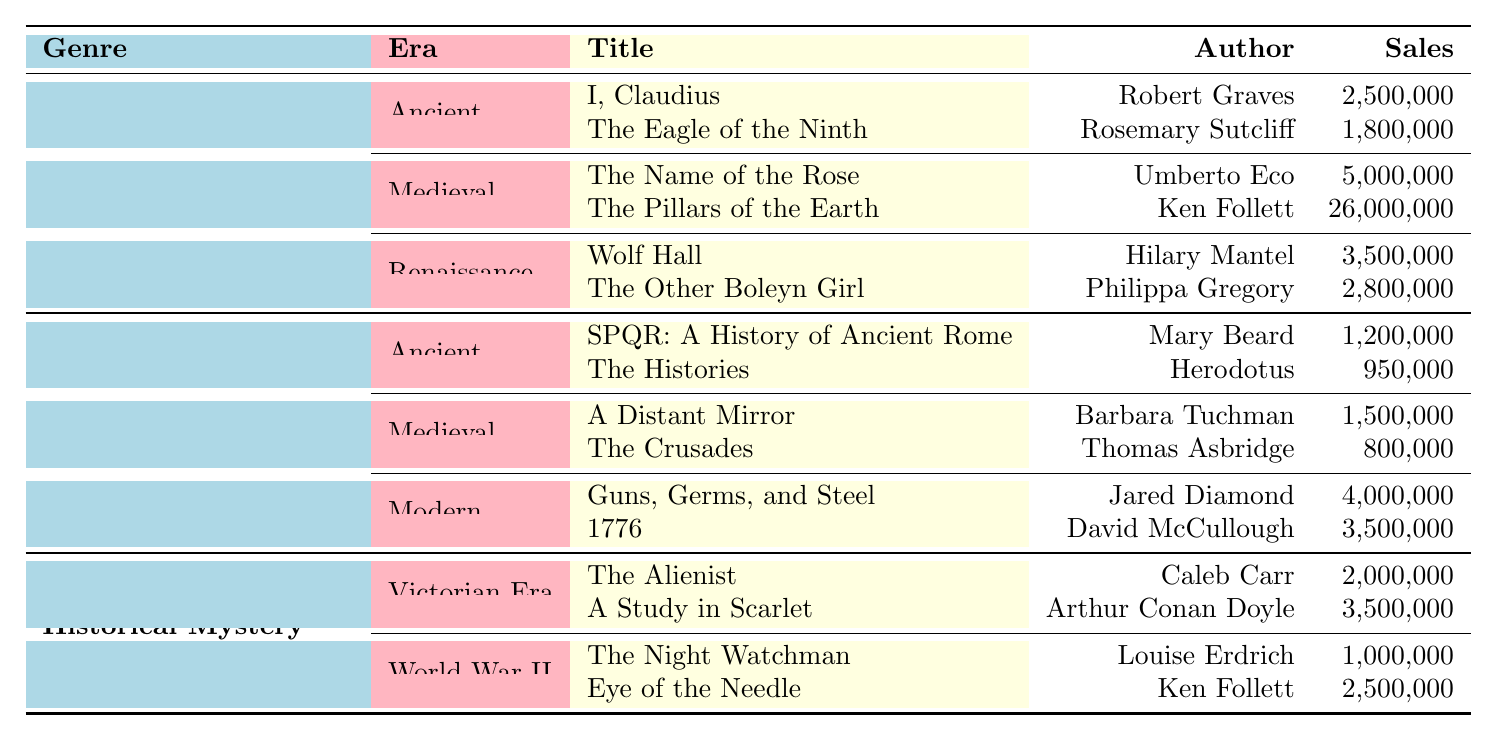What is the highest-selling historical fiction book listed? From the Historical Fiction section, "The Pillars of the Earth" by Ken Follett is shown to have sales of 26,000,000, which is higher than any other title in that category.
Answer: The Pillars of the Earth Which author has the highest total sales in historical fiction? To find the highest total sales by an author in historical fiction, we add the sales of "The Pillars of the Earth" (26,000,000) and "The Name of the Rose" (5,000,000) by Ken Follett and Umberto Eco, respectively. Ken Follett has the highest total sales of 26 million alone.
Answer: Ken Follett Is "The Histories" older than "Guns, Germs, and Steel"? "The Histories" by Herodotus was published in 1954 whereas "Guns, Germs, and Steel" by Jared Diamond was published in 1997. So yes, "The Histories" is older.
Answer: Yes What are the total sales of all the books under Historical Non-Fiction? We sum the sales of all books in Historical Non-Fiction: 1,200,000 + 950,000 + 1,500,000 + 800,000 + 4,000,000 + 3,500,000 = 12,950,000.
Answer: 12,950,000 How many books have sales exceeding 3 million? Counting the titles listed with sales over 3 million: "The Pillars of the Earth" (26,000,000), "The Name of the Rose" (5,000,000), "1776" (3,500,000), and "A Study in Scarlet" (3,500,000) gives us a total of 4 books.
Answer: 4 What is the average sales figure for historical mysteries? The total sales for historical mysteries: 2,000,000 + 3,500,000 + 1,000,000 + 2,500,000 = 9,000,000. There are 4 titles, so we divide: 9,000,000 / 4 = 2,250,000.
Answer: 2,250,000 Which genre has the highest total sales across all its time periods? We calculate the total sales for each genre: Historical Fiction = 2,500,000 + 1,800,000 + 5,000,000 + 26,000,000 + 3,500,000 + 2,800,000 = 42,600,000; Historical Non-Fiction = 1,200,000 + 950,000 + 1,500,000 + 800,000 + 4,000,000 + 3,500,000 = 12,950,000; Historical Mystery = 2,000,000 + 3,500,000 + 1,000,000 + 2,500,000 = 9,000,000. Historical Fiction has the highest total sales.
Answer: Historical Fiction Were there more sales in the Victorian era compared to World War II for historical mysteries? Victorian sales: 2,000,000 + 3,500,000 = 5,500,000; World War II sales: 1,000,000 + 2,500,000 = 3,500,000. Since 5,500,000 is greater than 3,500,000, the Victorian era had more sales.
Answer: Yes Which book has the least sales in the historical non-fiction category? From the Historical Non-Fiction section, "The Crusades" by Thomas Asbridge has the least sales of 800,000, compared to others which are higher.
Answer: The Crusades 